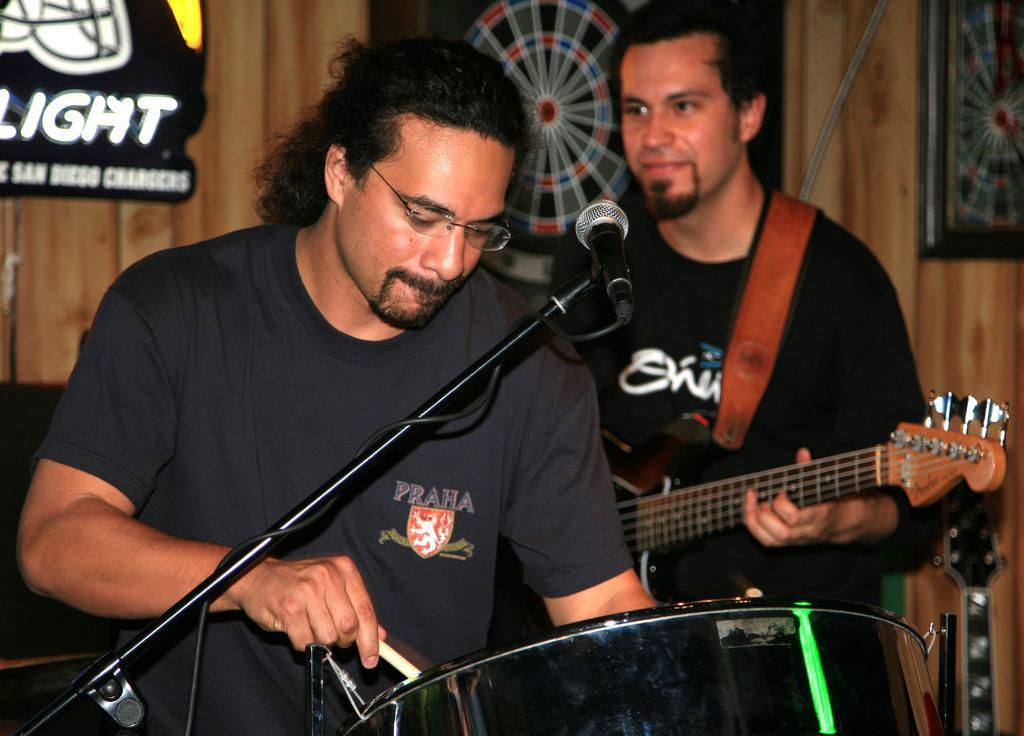In one or two sentences, can you explain what this image depicts? In this image there are two persons. One person is playing drums and the person at the back is playing guitar. At the back there are photo frames, at the front there is a microphone. 